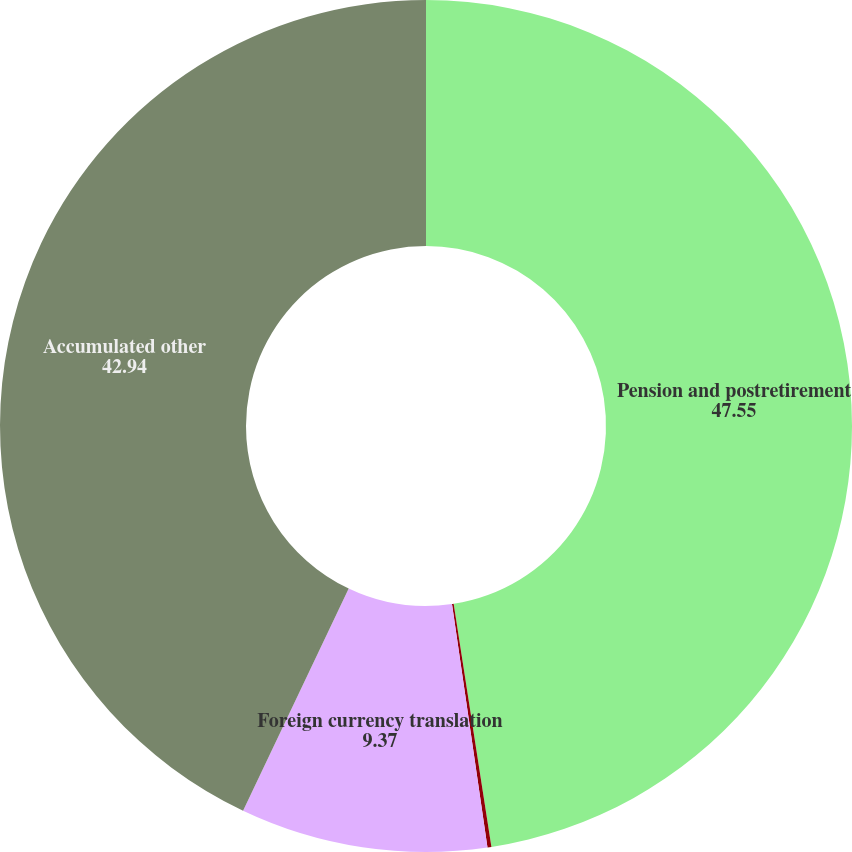Convert chart to OTSL. <chart><loc_0><loc_0><loc_500><loc_500><pie_chart><fcel>Pension and postretirement<fcel>Unrealized (losses)/gains on<fcel>Foreign currency translation<fcel>Accumulated other<nl><fcel>47.55%<fcel>0.15%<fcel>9.37%<fcel>42.94%<nl></chart> 